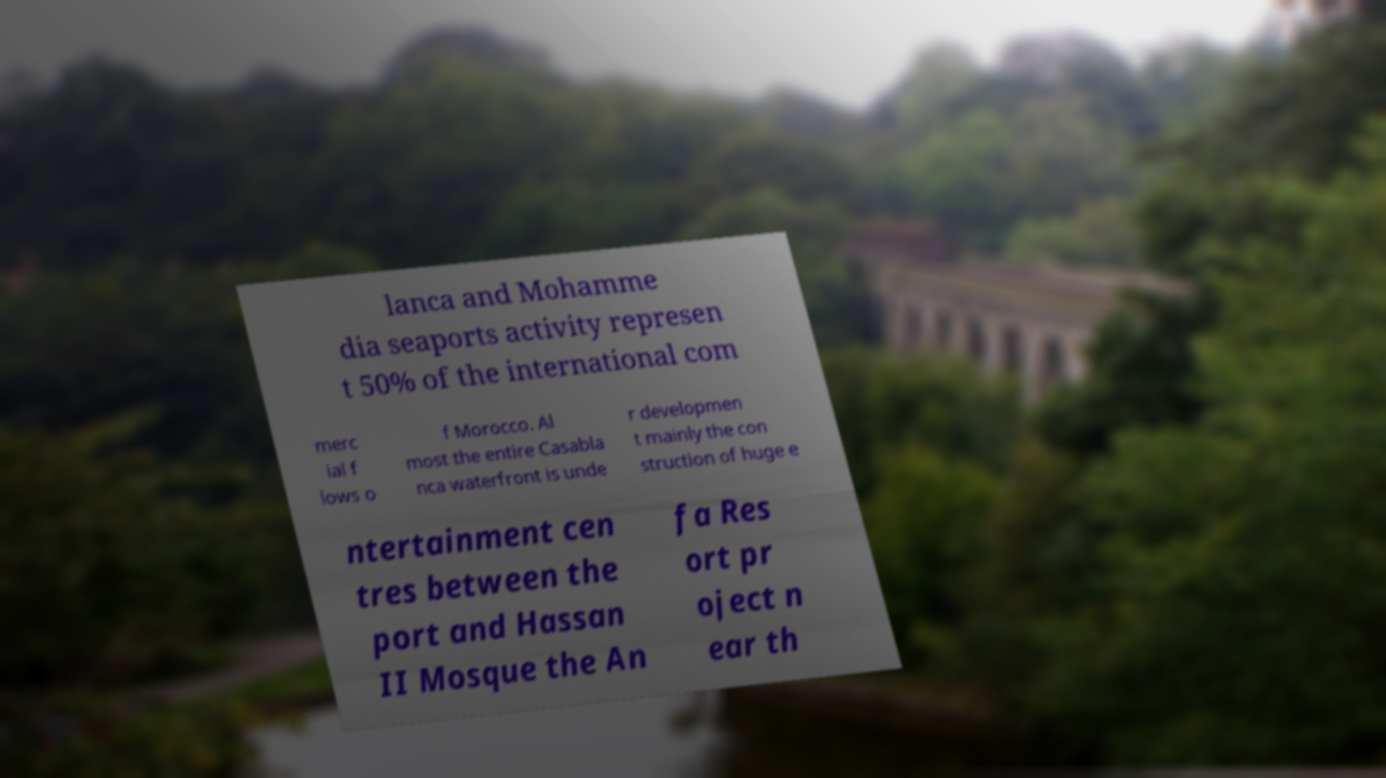Could you extract and type out the text from this image? lanca and Mohamme dia seaports activity represen t 50% of the international com merc ial f lows o f Morocco. Al most the entire Casabla nca waterfront is unde r developmen t mainly the con struction of huge e ntertainment cen tres between the port and Hassan II Mosque the An fa Res ort pr oject n ear th 